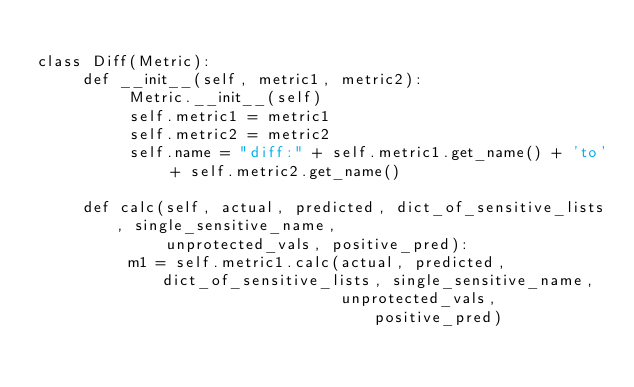Convert code to text. <code><loc_0><loc_0><loc_500><loc_500><_Python_>
class Diff(Metric):
     def __init__(self, metric1, metric2):
          Metric.__init__(self)
          self.metric1 = metric1
          self.metric2 = metric2
          self.name = "diff:" + self.metric1.get_name() + 'to' + self.metric2.get_name()

     def calc(self, actual, predicted, dict_of_sensitive_lists, single_sensitive_name,
              unprotected_vals, positive_pred):
          m1 = self.metric1.calc(actual, predicted, dict_of_sensitive_lists, single_sensitive_name,
                                 unprotected_vals, positive_pred)</code> 